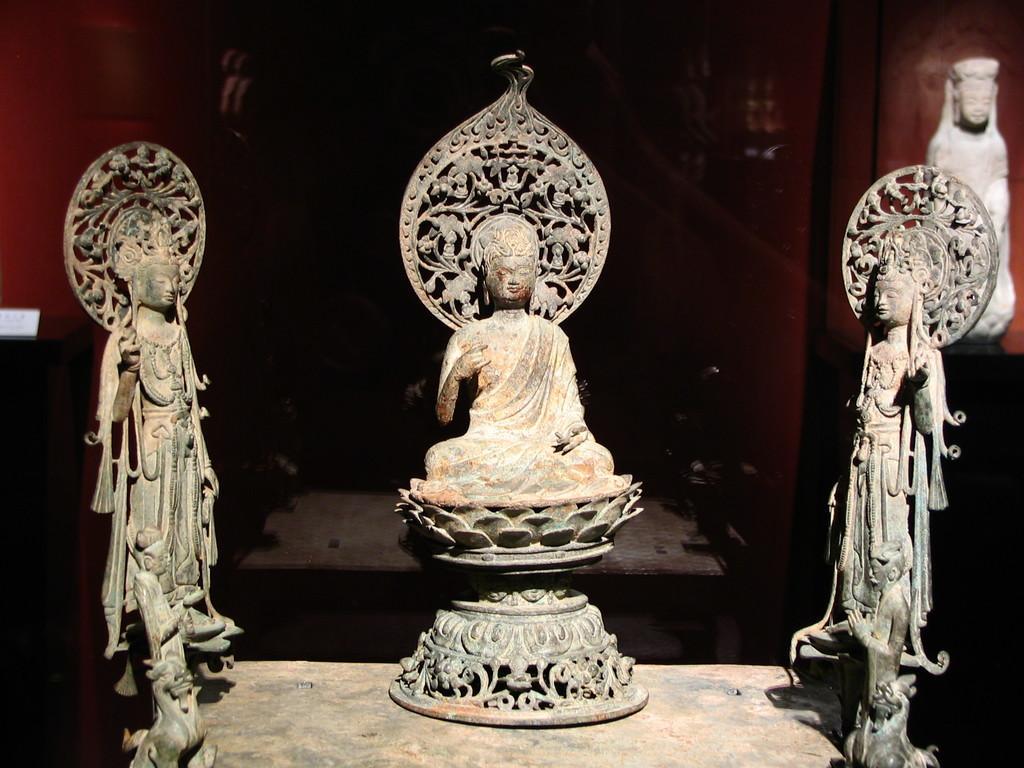How would you summarize this image in a sentence or two? In this picture we can see there are sculptures on the floor and behind the sculptures there is a wall. 